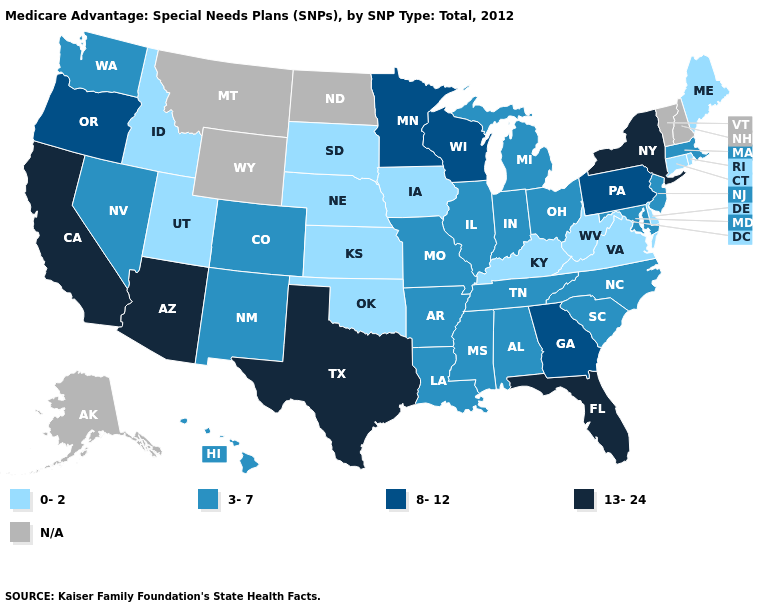Does the map have missing data?
Short answer required. Yes. Is the legend a continuous bar?
Give a very brief answer. No. Does Arizona have the highest value in the USA?
Be succinct. Yes. What is the value of Connecticut?
Short answer required. 0-2. Which states have the highest value in the USA?
Concise answer only. Arizona, California, Florida, New York, Texas. Does Hawaii have the lowest value in the USA?
Write a very short answer. No. Which states hav the highest value in the South?
Give a very brief answer. Florida, Texas. What is the value of Louisiana?
Be succinct. 3-7. What is the value of Alabama?
Concise answer only. 3-7. What is the highest value in the West ?
Quick response, please. 13-24. Which states have the lowest value in the MidWest?
Concise answer only. Iowa, Kansas, Nebraska, South Dakota. Which states hav the highest value in the South?
Keep it brief. Florida, Texas. Among the states that border Missouri , does Illinois have the highest value?
Be succinct. Yes. What is the highest value in the USA?
Concise answer only. 13-24. Name the states that have a value in the range 13-24?
Keep it brief. Arizona, California, Florida, New York, Texas. 